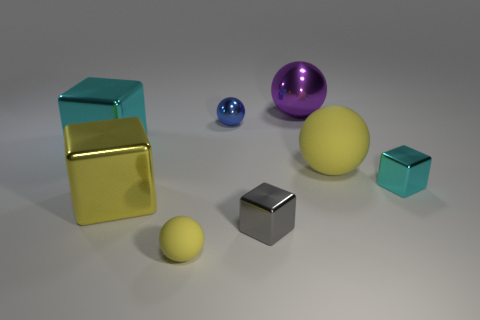Subtract 1 blocks. How many blocks are left? 3 Add 2 metal objects. How many objects exist? 10 Add 2 big shiny blocks. How many big shiny blocks exist? 4 Subtract 0 purple blocks. How many objects are left? 8 Subtract all big gray matte things. Subtract all gray metallic objects. How many objects are left? 7 Add 2 small cyan blocks. How many small cyan blocks are left? 3 